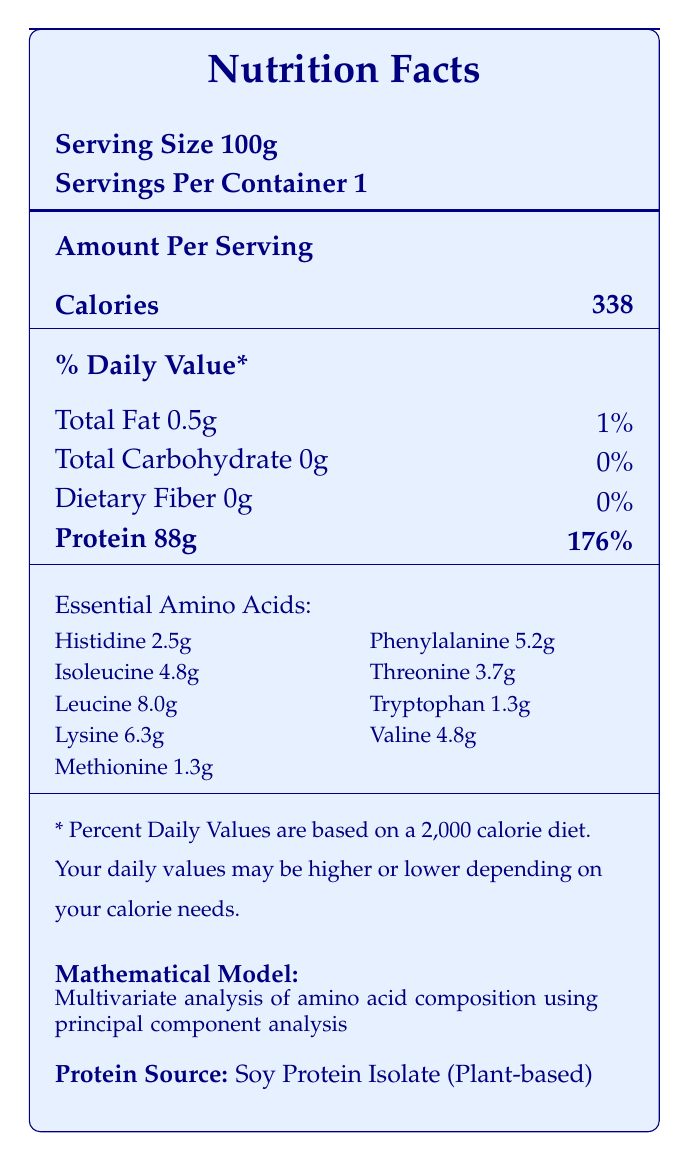what is the serving size? The document explicitly states that the serving size is 100g.
Answer: 100g how many servings are in each container? According to the document, there is 1 serving per container.
Answer: 1 how much protein is in one serving of Soy Protein Isolate? The document indicates that one serving of Soy Protein Isolate contains 88g of protein.
Answer: 88g what is the calorie content of Soy Protein Isolate per serving? The document lists the calorie content as 338 calories per serving.
Answer: 338 how many essential amino acids are listed for Soy Protein Isolate? The document lists the quantities of 9 essential amino acids for Soy Protein Isolate (histidine, isoleucine, leucine, lysine, methionine, phenylalanine, threonine, tryptophan, valine).
Answer: 9 which mathematical model is used for Soy Protein Isolate? A. Multivariate Analysis of Variance (MANOVA) B. Canonical Correlation Analysis C. Principal Component Analysis D. Cluster Analysis The document specifies that the mathematical model used for Soy Protein Isolate is principal component analysis.
Answer: C which protein source has the highest caloric content per serving? A. Soy Protein Isolate B. Whey Protein Isolate C. Pea Protein Isolate D. Egg White Protein Pea Protein Isolate has the highest caloric content with 373 calories per serving.
Answer: C is the total carbohydrate content in Soy Protein Isolate more than 1g? The document states that Soy Protein Isolate has 0g of carbohydrates.
Answer: No how much leucine is present in Soy Protein Isolate per serving? The document lists the leucine content as 8.0g per serving for Soy Protein Isolate.
Answer: 8.0g what type of protein is Soy Protein Isolate considered? The document identifies Soy Protein Isolate as a plant-based protein source.
Answer: Plant-based compare the amount of methionine in Soy Protein Isolate and Whey Protein Isolate. The document indicates that Soy Protein Isolate contains 1.3g of methionine, while Whey Protein Isolate contains 2.2g.
Answer: Soy Protein Isolate: 1.3g, Whey Protein Isolate: 2.2g what type of analysis is used to compare essential amino acid profiles between protein sources? The document indicates that MANOVA is used to compare the essential amino acid profiles of plant-based and animal protein sources.
Answer: Multivariate Analysis of Variance (MANOVA) which essential amino acid is present in the lowest amount in Soy Protein Isolate? Methionine has the lowest content at 1.3g in Soy Protein Isolate, according to the document.
Answer: Methionine summarize the main idea of the document. The document aims to provide a comprehensive comparison of plant-based and animal protein sources in terms of their nutritional content and essential amino acid profiles, using various mathematical and statistical analyses.
Answer: The document compares the nutritional profiles of different plant-based and animal protein sources, focusing on essential amino acid ratios and various protein quality metrics. It includes a detailed nutritional breakdown of serving sizes, calories, macronutrients, and essential amino acids for each protein source. The document also describes different mathematical models and methods used to analyze and compare these proteins. which protein source is used in "Canonical correlation analysis of protein quality and digestibility"? The document reveals that Whey Protein Isolate uses canonical correlation analysis to evaluate protein quality and digestibility.
Answer: Whey Protein Isolate what is the percentage of daily value for protein in Soy Protein Isolate per serving? The document states that one serving of Soy Protein Isolate provides 176% of the daily value for protein.
Answer: 176% how does the document describe PDCAAS? The document describes PDCAAS as a method to evaluate protein quality by accounting for amino acid requirements and digestibility.
Answer: A method of evaluating protein quality based on both the amino acid requirements of humans and their ability to digest it. what is the mathematical formula for DIAAS? The document provides this formula for calculating DIAAS.
Answer: DIAAS = 100 × (mg of digestible dietary indispensable amino acid in 1 g of the dietary protein) / (mg of the same dietary indispensable amino acid in 1 g of the reference protein) how much fiber is in one serving of Soy Protein Isolate? The document lists the fiber content of Soy Protein Isolate as 0g per serving.
Answer: 0g what is the main nutritional difference between Soy Protein Isolate and Egg White Protein? The key difference noted in the document is that Soy Protein Isolate contains 88g of protein and 0.5g fat per serving, while Egg White Protein contains 82g of protein and no fat per serving.
Answer: Soy Protein Isolate has higher protein content with 88g compared to Egg White Protein's 82g per serving, and Egg White Protein has no fat compared to Soy Protein Isolate's 0.5g fat. what is the limiting amino acid score used in the PDCAAS formula? The document does not provide specific information on the limiting amino acid score used in the PDCAAS formula.
Answer: Cannot be determined 